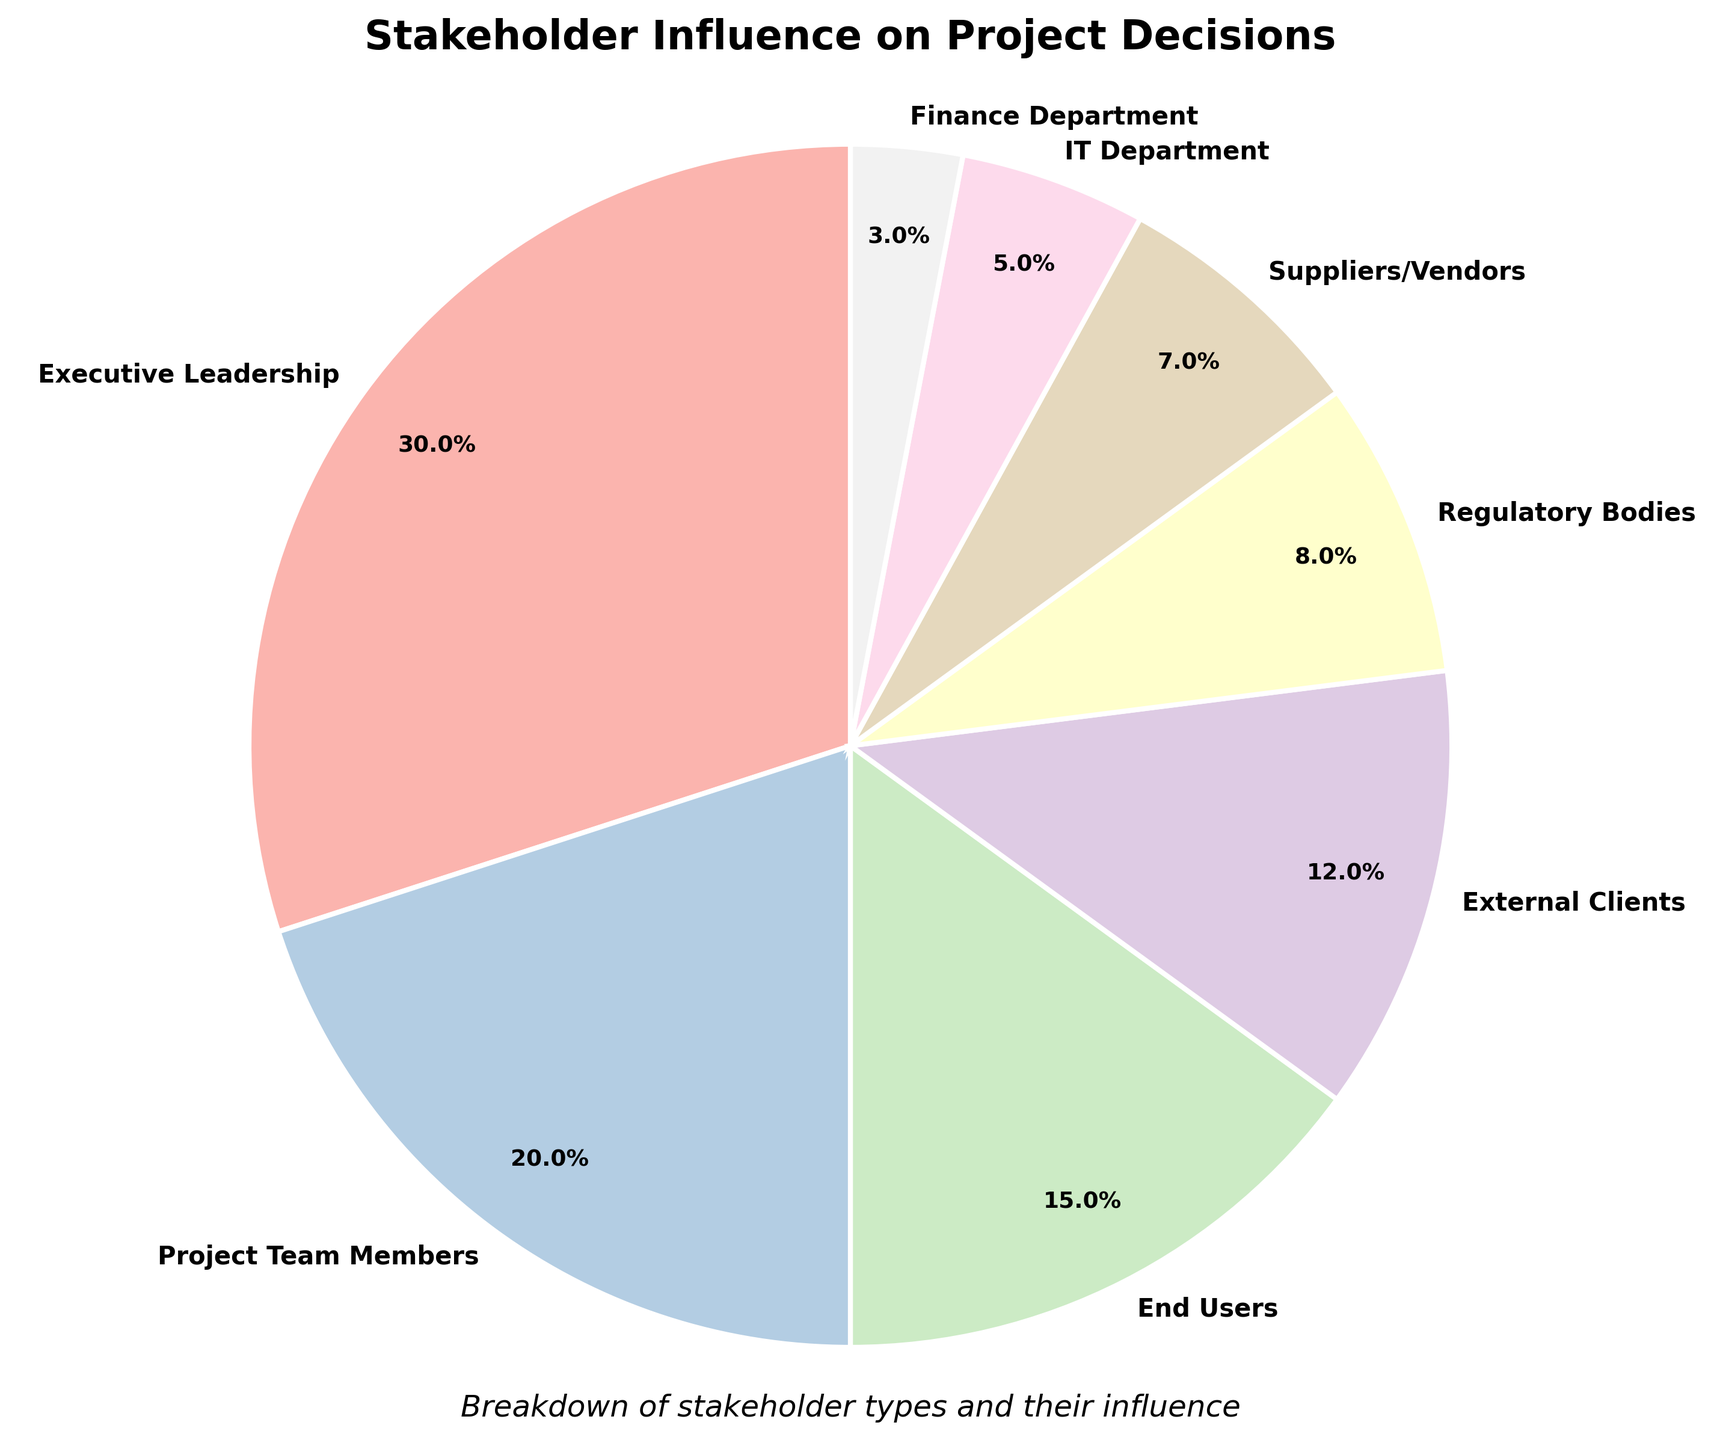Which stakeholder type has the highest influence on project decisions? The pie chart shows that "Executive Leadership" has the largest slice of the pie, which means they have the highest influence percentage.
Answer: Executive Leadership What percentage of influence do external clients and regulatory bodies hold together? Add the percentage influence of External Clients (12) and Regulatory Bodies (8). So, 12 + 8 = 20.
Answer: 20% How does the influence of the IT Department compare to that of the Finance Department? The chart indicates that the IT Department has a 5% influence, while the Finance Department has a 3% influence. Therefore, IT Department has a higher influence.
Answer: IT Department has a higher influence Which stakeholder types have an influence percentage below 10%? The pie chart shows that Regulatory Bodies, Suppliers/Vendors, IT Department, and Finance Department all have influence percentages below 10% (8%, 7%, 5%, and 3% respectively).
Answer: Regulatory Bodies, Suppliers/Vendors, IT Department, Finance Department What's the combined influence percentage of all stakeholders except Executive Leadership and Project Team Members? Subtract the sum of the influence percentages of Executive Leadership (30%) and Project Team Members (20%) from 100%. So, 100 - 30 - 20 = 50.
Answer: 50% Which two stakeholder types together provide an influence over 35%? The chart shows that Executive Leadership (30%) and any one other stakeholder with more than 5% can combine to over 35%. Executive Leadership (30%) + Project Team Members (20%) = 50%, and Executive Leadership (30%) + End Users (15%) = 45%.
Answer: Executive Leadership and Project Team Members, or Executive Leadership and End Users What is the influence percentage difference between the most and least influential stakeholder types? The most influential is Executive Leadership with 30%, and the least influential is the Finance Department with 3%. Therefore, the difference is 30 - 3 = 27.
Answer: 27% What color represents the End Users in the pie chart? The pie chart uses a custom color map (Pastel1) but from visual inspection, we can identify the specific color segment labeled "End Users."
Answer: Color corresponding to the third largest slice (Pastel1 shade) How many stakeholder types have an influence of at least 5% but less than 20%? The chart shows Project Team Members (20%), End Users (15%), External Clients (12%), Regulatory Bodies (8%), and Suppliers/Vendors (7%). Excluding Project Team Members (20%), there are four stakeholder types: End Users, External Clients, Regulatory Bodies, and Suppliers/Vendors.
Answer: Four Which stakeholder types together make up exactly 50% of the influence? Identify combinations of stakeholder types whose percentages add up to 50%. The possible set is Executive Leadership (30%) + Project Team Members (20%) = 50%.
Answer: Executive Leadership and Project Team Members 